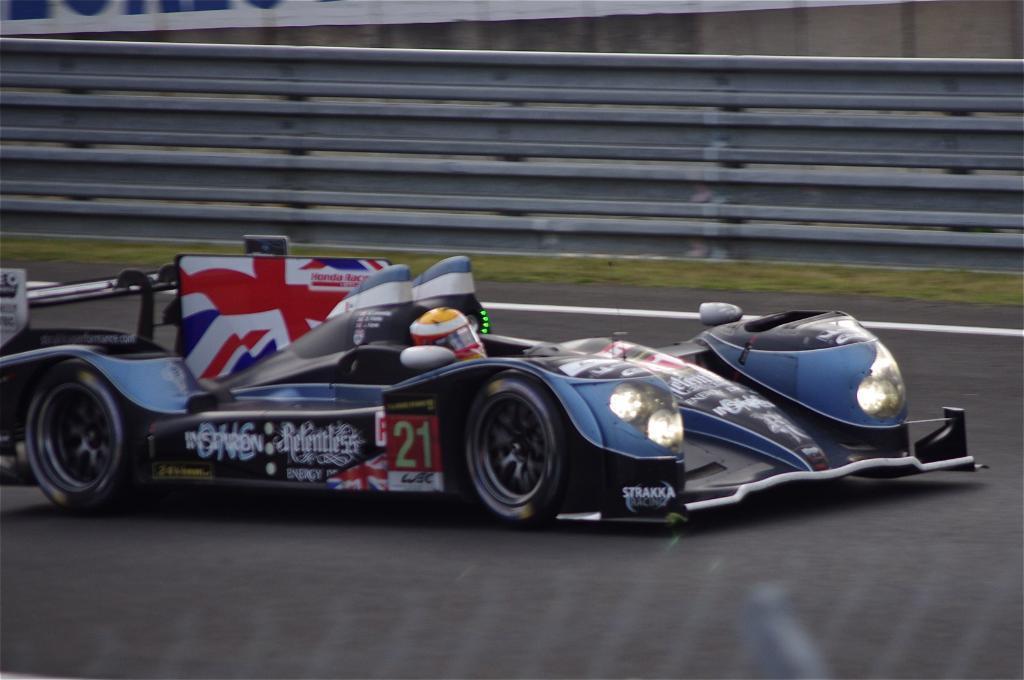Describe this image in one or two sentences. In this image a person is sitting on the car which is on the road. Person is wearing a helmet. Beside the road there is a fence on the grass land. Top of the image there is a banner attached to the wall. 